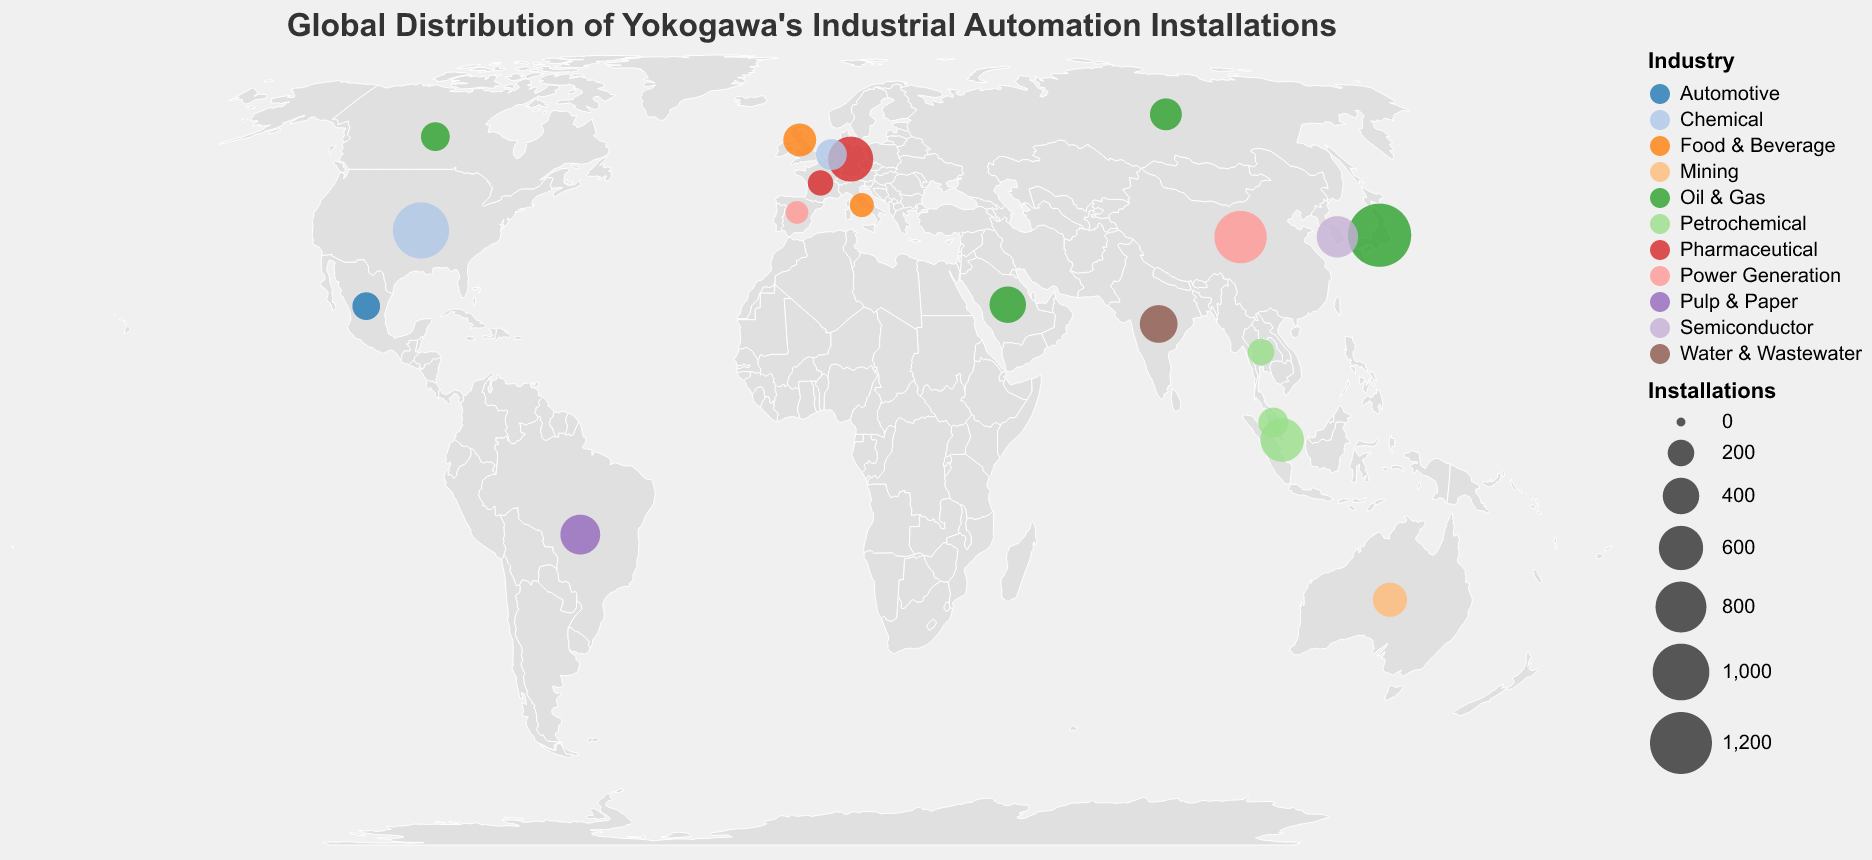How many installations are there in Japan for the Oil & Gas industry? By looking at the point on the map corresponding to Japan and examining the tooltip, we see that Japan has 1250 installations for the Oil & Gas industry.
Answer: 1250 Which country has the highest number of industrial automation installations? Observing the sizes of the circles on the map, Japan has the largest circle, indicating the highest number of installations. The tooltip confirms Japan has 1250 installations.
Answer: Japan What is the total number of installations in countries with "Oil & Gas" as their industry sector? Adding up the installations for Japan (1250), Saudi Arabia (400), Russia (300), and Canada (240) from the map and tooltips results in 1250 + 400 + 300 + 240 = 2190.
Answer: 2190 Which country has the greatest number of installations in the Petrochemical industry? By comparing the circles for Singapore (580), Malaysia (260), and Thailand (200), Singapore has the largest circle. The tooltip confirms Singapore has 580 installations.
Answer: Singapore Are there more chemical industry installations in the United States or the Netherlands? Comparing the circles for the United States (980) and the Netherlands (280), the United States has a larger circle. The tooltip confirms the United States has 980 installations.
Answer: United States What is the average number of installations in the Pharmaceutical industry across the relevant countries? The Pharmaceutical industry installations are in Germany (620) and France (180). Calculating the average: (620 + 180) / 2 = 800 / 2 = 400.
Answer: 400 Which industry has the most variation in the number of installations among different countries? By comparing the industries and their respective circles' sizes on the map, the Oil & Gas industry (Japan has 1250, Saudi Arabia 400, Russia 300, and Canada 240) shows significant variation between 1250 and 240. Other industries have less variation between countries.
Answer: Oil & Gas How does the number of installations in China compare to those in the United States? The United States has 980 installations and China has 850 installations, as shown by tooltips on their respective circles. So, the United States has more installations.
Answer: United States has more installations What is the total number of installations for countries in Asia? Summing the installations for Japan (1250), China (850), Singapore (580), South Korea (520), India (430), Saudi Arabia (400), Malaysia (260), and Thailand (200): 1250 + 850 + 580 + 520 + 430 + 400 + 260 + 200 = 4490.
Answer: 4490 Which country in Europe has the fewest installations, and what is the industry? By examining the circles for European countries, the smallest is for Spain with an industry sector of Power Generation, having 140 installations as per the tooltip.
Answer: Spain, Power Generation 